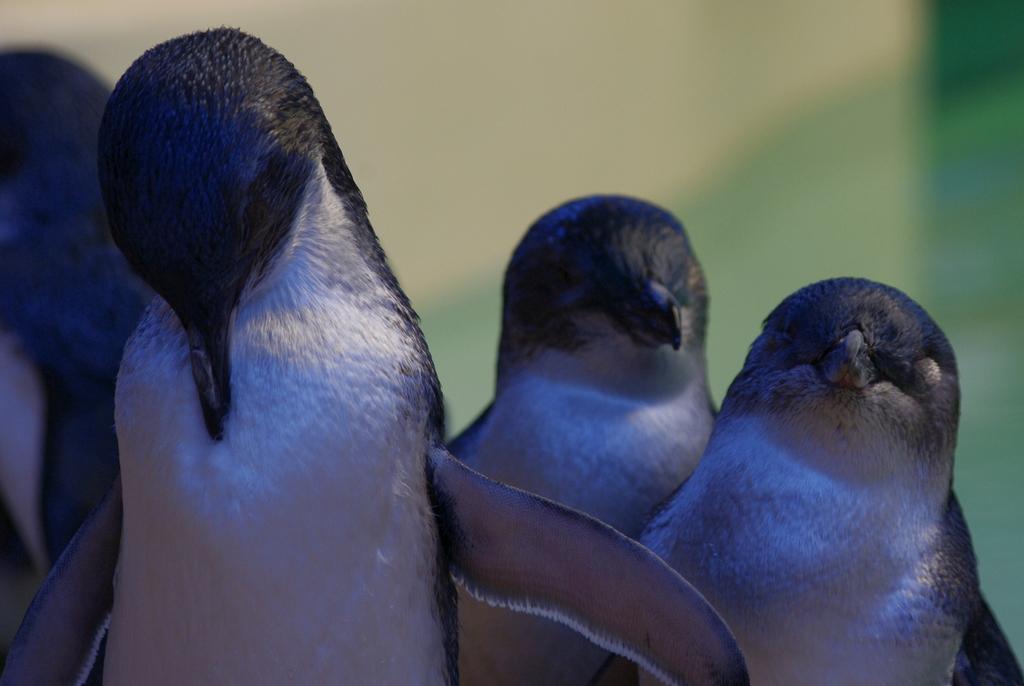Could you give a brief overview of what you see in this image? This image is taken outdoors. In this image the background is a little blurred. In the middle of the image there are four penguins. 